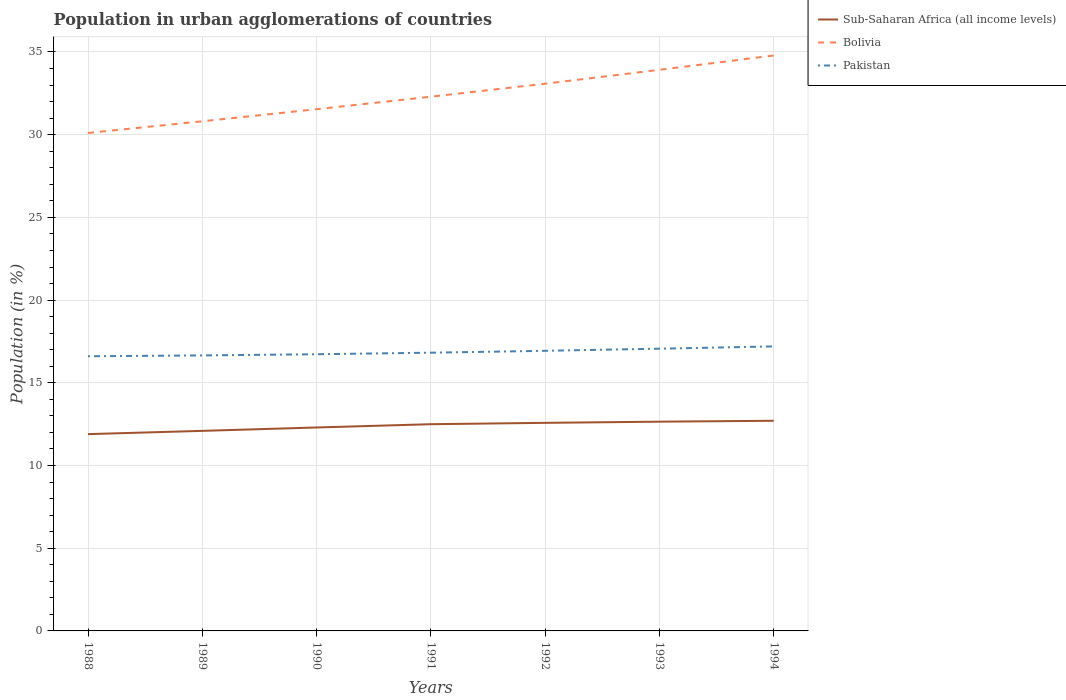Does the line corresponding to Pakistan intersect with the line corresponding to Bolivia?
Ensure brevity in your answer.  No. Is the number of lines equal to the number of legend labels?
Your response must be concise. Yes. Across all years, what is the maximum percentage of population in urban agglomerations in Pakistan?
Keep it short and to the point. 16.61. What is the total percentage of population in urban agglomerations in Bolivia in the graph?
Keep it short and to the point. -0.87. What is the difference between the highest and the second highest percentage of population in urban agglomerations in Bolivia?
Offer a very short reply. 4.68. What is the difference between the highest and the lowest percentage of population in urban agglomerations in Bolivia?
Give a very brief answer. 3. Is the percentage of population in urban agglomerations in Pakistan strictly greater than the percentage of population in urban agglomerations in Sub-Saharan Africa (all income levels) over the years?
Provide a short and direct response. No. What is the difference between two consecutive major ticks on the Y-axis?
Make the answer very short. 5. Are the values on the major ticks of Y-axis written in scientific E-notation?
Your response must be concise. No. Does the graph contain grids?
Offer a terse response. Yes. Where does the legend appear in the graph?
Make the answer very short. Top right. How many legend labels are there?
Make the answer very short. 3. What is the title of the graph?
Make the answer very short. Population in urban agglomerations of countries. What is the label or title of the Y-axis?
Make the answer very short. Population (in %). What is the Population (in %) in Sub-Saharan Africa (all income levels) in 1988?
Your answer should be very brief. 11.9. What is the Population (in %) of Bolivia in 1988?
Provide a succinct answer. 30.11. What is the Population (in %) of Pakistan in 1988?
Offer a terse response. 16.61. What is the Population (in %) of Sub-Saharan Africa (all income levels) in 1989?
Your answer should be very brief. 12.1. What is the Population (in %) in Bolivia in 1989?
Offer a terse response. 30.81. What is the Population (in %) in Pakistan in 1989?
Give a very brief answer. 16.66. What is the Population (in %) in Sub-Saharan Africa (all income levels) in 1990?
Ensure brevity in your answer.  12.3. What is the Population (in %) in Bolivia in 1990?
Keep it short and to the point. 31.54. What is the Population (in %) in Pakistan in 1990?
Keep it short and to the point. 16.73. What is the Population (in %) of Sub-Saharan Africa (all income levels) in 1991?
Keep it short and to the point. 12.5. What is the Population (in %) in Bolivia in 1991?
Provide a short and direct response. 32.3. What is the Population (in %) of Pakistan in 1991?
Ensure brevity in your answer.  16.82. What is the Population (in %) of Sub-Saharan Africa (all income levels) in 1992?
Ensure brevity in your answer.  12.58. What is the Population (in %) in Bolivia in 1992?
Offer a terse response. 33.08. What is the Population (in %) in Pakistan in 1992?
Keep it short and to the point. 16.94. What is the Population (in %) of Sub-Saharan Africa (all income levels) in 1993?
Your answer should be very brief. 12.65. What is the Population (in %) in Bolivia in 1993?
Offer a terse response. 33.92. What is the Population (in %) in Pakistan in 1993?
Your response must be concise. 17.06. What is the Population (in %) of Sub-Saharan Africa (all income levels) in 1994?
Offer a terse response. 12.71. What is the Population (in %) in Bolivia in 1994?
Make the answer very short. 34.79. What is the Population (in %) in Pakistan in 1994?
Offer a terse response. 17.2. Across all years, what is the maximum Population (in %) in Sub-Saharan Africa (all income levels)?
Your response must be concise. 12.71. Across all years, what is the maximum Population (in %) in Bolivia?
Keep it short and to the point. 34.79. Across all years, what is the maximum Population (in %) of Pakistan?
Provide a succinct answer. 17.2. Across all years, what is the minimum Population (in %) in Sub-Saharan Africa (all income levels)?
Provide a succinct answer. 11.9. Across all years, what is the minimum Population (in %) of Bolivia?
Offer a very short reply. 30.11. Across all years, what is the minimum Population (in %) in Pakistan?
Provide a succinct answer. 16.61. What is the total Population (in %) of Sub-Saharan Africa (all income levels) in the graph?
Your answer should be very brief. 86.73. What is the total Population (in %) in Bolivia in the graph?
Provide a succinct answer. 226.55. What is the total Population (in %) in Pakistan in the graph?
Give a very brief answer. 118.01. What is the difference between the Population (in %) of Sub-Saharan Africa (all income levels) in 1988 and that in 1989?
Ensure brevity in your answer.  -0.2. What is the difference between the Population (in %) in Bolivia in 1988 and that in 1989?
Give a very brief answer. -0.71. What is the difference between the Population (in %) of Pakistan in 1988 and that in 1989?
Make the answer very short. -0.05. What is the difference between the Population (in %) of Sub-Saharan Africa (all income levels) in 1988 and that in 1990?
Ensure brevity in your answer.  -0.4. What is the difference between the Population (in %) in Bolivia in 1988 and that in 1990?
Provide a succinct answer. -1.44. What is the difference between the Population (in %) of Pakistan in 1988 and that in 1990?
Provide a succinct answer. -0.12. What is the difference between the Population (in %) in Sub-Saharan Africa (all income levels) in 1988 and that in 1991?
Ensure brevity in your answer.  -0.6. What is the difference between the Population (in %) of Bolivia in 1988 and that in 1991?
Offer a very short reply. -2.19. What is the difference between the Population (in %) of Pakistan in 1988 and that in 1991?
Your answer should be very brief. -0.21. What is the difference between the Population (in %) in Sub-Saharan Africa (all income levels) in 1988 and that in 1992?
Keep it short and to the point. -0.68. What is the difference between the Population (in %) of Bolivia in 1988 and that in 1992?
Your answer should be compact. -2.98. What is the difference between the Population (in %) of Pakistan in 1988 and that in 1992?
Give a very brief answer. -0.33. What is the difference between the Population (in %) of Sub-Saharan Africa (all income levels) in 1988 and that in 1993?
Offer a very short reply. -0.75. What is the difference between the Population (in %) in Bolivia in 1988 and that in 1993?
Provide a short and direct response. -3.82. What is the difference between the Population (in %) in Pakistan in 1988 and that in 1993?
Your answer should be very brief. -0.46. What is the difference between the Population (in %) of Sub-Saharan Africa (all income levels) in 1988 and that in 1994?
Make the answer very short. -0.81. What is the difference between the Population (in %) in Bolivia in 1988 and that in 1994?
Make the answer very short. -4.68. What is the difference between the Population (in %) in Pakistan in 1988 and that in 1994?
Ensure brevity in your answer.  -0.6. What is the difference between the Population (in %) of Sub-Saharan Africa (all income levels) in 1989 and that in 1990?
Offer a terse response. -0.2. What is the difference between the Population (in %) in Bolivia in 1989 and that in 1990?
Offer a very short reply. -0.73. What is the difference between the Population (in %) of Pakistan in 1989 and that in 1990?
Provide a succinct answer. -0.07. What is the difference between the Population (in %) of Sub-Saharan Africa (all income levels) in 1989 and that in 1991?
Offer a very short reply. -0.4. What is the difference between the Population (in %) of Bolivia in 1989 and that in 1991?
Keep it short and to the point. -1.49. What is the difference between the Population (in %) of Pakistan in 1989 and that in 1991?
Your response must be concise. -0.16. What is the difference between the Population (in %) in Sub-Saharan Africa (all income levels) in 1989 and that in 1992?
Offer a very short reply. -0.48. What is the difference between the Population (in %) in Bolivia in 1989 and that in 1992?
Provide a succinct answer. -2.27. What is the difference between the Population (in %) in Pakistan in 1989 and that in 1992?
Keep it short and to the point. -0.28. What is the difference between the Population (in %) in Sub-Saharan Africa (all income levels) in 1989 and that in 1993?
Offer a terse response. -0.56. What is the difference between the Population (in %) of Bolivia in 1989 and that in 1993?
Ensure brevity in your answer.  -3.11. What is the difference between the Population (in %) of Pakistan in 1989 and that in 1993?
Your answer should be very brief. -0.41. What is the difference between the Population (in %) in Sub-Saharan Africa (all income levels) in 1989 and that in 1994?
Offer a very short reply. -0.61. What is the difference between the Population (in %) of Bolivia in 1989 and that in 1994?
Ensure brevity in your answer.  -3.98. What is the difference between the Population (in %) of Pakistan in 1989 and that in 1994?
Offer a very short reply. -0.55. What is the difference between the Population (in %) of Sub-Saharan Africa (all income levels) in 1990 and that in 1991?
Keep it short and to the point. -0.2. What is the difference between the Population (in %) of Bolivia in 1990 and that in 1991?
Your answer should be compact. -0.76. What is the difference between the Population (in %) of Pakistan in 1990 and that in 1991?
Keep it short and to the point. -0.09. What is the difference between the Population (in %) of Sub-Saharan Africa (all income levels) in 1990 and that in 1992?
Offer a terse response. -0.28. What is the difference between the Population (in %) in Bolivia in 1990 and that in 1992?
Your answer should be compact. -1.54. What is the difference between the Population (in %) in Pakistan in 1990 and that in 1992?
Make the answer very short. -0.21. What is the difference between the Population (in %) in Sub-Saharan Africa (all income levels) in 1990 and that in 1993?
Ensure brevity in your answer.  -0.35. What is the difference between the Population (in %) in Bolivia in 1990 and that in 1993?
Provide a succinct answer. -2.38. What is the difference between the Population (in %) in Pakistan in 1990 and that in 1993?
Ensure brevity in your answer.  -0.34. What is the difference between the Population (in %) of Sub-Saharan Africa (all income levels) in 1990 and that in 1994?
Your response must be concise. -0.41. What is the difference between the Population (in %) of Bolivia in 1990 and that in 1994?
Keep it short and to the point. -3.25. What is the difference between the Population (in %) of Pakistan in 1990 and that in 1994?
Offer a terse response. -0.47. What is the difference between the Population (in %) in Sub-Saharan Africa (all income levels) in 1991 and that in 1992?
Your response must be concise. -0.08. What is the difference between the Population (in %) of Bolivia in 1991 and that in 1992?
Give a very brief answer. -0.79. What is the difference between the Population (in %) of Pakistan in 1991 and that in 1992?
Make the answer very short. -0.11. What is the difference between the Population (in %) of Sub-Saharan Africa (all income levels) in 1991 and that in 1993?
Your answer should be very brief. -0.15. What is the difference between the Population (in %) in Bolivia in 1991 and that in 1993?
Your answer should be compact. -1.63. What is the difference between the Population (in %) of Pakistan in 1991 and that in 1993?
Your answer should be compact. -0.24. What is the difference between the Population (in %) of Sub-Saharan Africa (all income levels) in 1991 and that in 1994?
Give a very brief answer. -0.21. What is the difference between the Population (in %) of Bolivia in 1991 and that in 1994?
Your response must be concise. -2.49. What is the difference between the Population (in %) of Pakistan in 1991 and that in 1994?
Make the answer very short. -0.38. What is the difference between the Population (in %) in Sub-Saharan Africa (all income levels) in 1992 and that in 1993?
Keep it short and to the point. -0.07. What is the difference between the Population (in %) of Bolivia in 1992 and that in 1993?
Give a very brief answer. -0.84. What is the difference between the Population (in %) in Pakistan in 1992 and that in 1993?
Provide a succinct answer. -0.13. What is the difference between the Population (in %) of Sub-Saharan Africa (all income levels) in 1992 and that in 1994?
Ensure brevity in your answer.  -0.13. What is the difference between the Population (in %) in Bolivia in 1992 and that in 1994?
Your answer should be very brief. -1.7. What is the difference between the Population (in %) of Pakistan in 1992 and that in 1994?
Your answer should be compact. -0.27. What is the difference between the Population (in %) of Sub-Saharan Africa (all income levels) in 1993 and that in 1994?
Give a very brief answer. -0.06. What is the difference between the Population (in %) in Bolivia in 1993 and that in 1994?
Offer a very short reply. -0.86. What is the difference between the Population (in %) of Pakistan in 1993 and that in 1994?
Provide a short and direct response. -0.14. What is the difference between the Population (in %) of Sub-Saharan Africa (all income levels) in 1988 and the Population (in %) of Bolivia in 1989?
Make the answer very short. -18.91. What is the difference between the Population (in %) in Sub-Saharan Africa (all income levels) in 1988 and the Population (in %) in Pakistan in 1989?
Keep it short and to the point. -4.76. What is the difference between the Population (in %) in Bolivia in 1988 and the Population (in %) in Pakistan in 1989?
Offer a very short reply. 13.45. What is the difference between the Population (in %) of Sub-Saharan Africa (all income levels) in 1988 and the Population (in %) of Bolivia in 1990?
Keep it short and to the point. -19.64. What is the difference between the Population (in %) in Sub-Saharan Africa (all income levels) in 1988 and the Population (in %) in Pakistan in 1990?
Ensure brevity in your answer.  -4.83. What is the difference between the Population (in %) in Bolivia in 1988 and the Population (in %) in Pakistan in 1990?
Your response must be concise. 13.38. What is the difference between the Population (in %) of Sub-Saharan Africa (all income levels) in 1988 and the Population (in %) of Bolivia in 1991?
Offer a very short reply. -20.4. What is the difference between the Population (in %) of Sub-Saharan Africa (all income levels) in 1988 and the Population (in %) of Pakistan in 1991?
Provide a short and direct response. -4.92. What is the difference between the Population (in %) of Bolivia in 1988 and the Population (in %) of Pakistan in 1991?
Keep it short and to the point. 13.28. What is the difference between the Population (in %) of Sub-Saharan Africa (all income levels) in 1988 and the Population (in %) of Bolivia in 1992?
Your response must be concise. -21.19. What is the difference between the Population (in %) in Sub-Saharan Africa (all income levels) in 1988 and the Population (in %) in Pakistan in 1992?
Ensure brevity in your answer.  -5.04. What is the difference between the Population (in %) in Bolivia in 1988 and the Population (in %) in Pakistan in 1992?
Make the answer very short. 13.17. What is the difference between the Population (in %) in Sub-Saharan Africa (all income levels) in 1988 and the Population (in %) in Bolivia in 1993?
Offer a terse response. -22.03. What is the difference between the Population (in %) in Sub-Saharan Africa (all income levels) in 1988 and the Population (in %) in Pakistan in 1993?
Your answer should be very brief. -5.17. What is the difference between the Population (in %) in Bolivia in 1988 and the Population (in %) in Pakistan in 1993?
Offer a terse response. 13.04. What is the difference between the Population (in %) of Sub-Saharan Africa (all income levels) in 1988 and the Population (in %) of Bolivia in 1994?
Provide a short and direct response. -22.89. What is the difference between the Population (in %) of Sub-Saharan Africa (all income levels) in 1988 and the Population (in %) of Pakistan in 1994?
Your answer should be very brief. -5.3. What is the difference between the Population (in %) of Bolivia in 1988 and the Population (in %) of Pakistan in 1994?
Your answer should be compact. 12.9. What is the difference between the Population (in %) in Sub-Saharan Africa (all income levels) in 1989 and the Population (in %) in Bolivia in 1990?
Your answer should be very brief. -19.45. What is the difference between the Population (in %) of Sub-Saharan Africa (all income levels) in 1989 and the Population (in %) of Pakistan in 1990?
Provide a short and direct response. -4.63. What is the difference between the Population (in %) of Bolivia in 1989 and the Population (in %) of Pakistan in 1990?
Give a very brief answer. 14.08. What is the difference between the Population (in %) of Sub-Saharan Africa (all income levels) in 1989 and the Population (in %) of Bolivia in 1991?
Offer a terse response. -20.2. What is the difference between the Population (in %) in Sub-Saharan Africa (all income levels) in 1989 and the Population (in %) in Pakistan in 1991?
Your answer should be compact. -4.73. What is the difference between the Population (in %) in Bolivia in 1989 and the Population (in %) in Pakistan in 1991?
Make the answer very short. 13.99. What is the difference between the Population (in %) of Sub-Saharan Africa (all income levels) in 1989 and the Population (in %) of Bolivia in 1992?
Keep it short and to the point. -20.99. What is the difference between the Population (in %) in Sub-Saharan Africa (all income levels) in 1989 and the Population (in %) in Pakistan in 1992?
Make the answer very short. -4.84. What is the difference between the Population (in %) in Bolivia in 1989 and the Population (in %) in Pakistan in 1992?
Provide a succinct answer. 13.88. What is the difference between the Population (in %) of Sub-Saharan Africa (all income levels) in 1989 and the Population (in %) of Bolivia in 1993?
Give a very brief answer. -21.83. What is the difference between the Population (in %) in Sub-Saharan Africa (all income levels) in 1989 and the Population (in %) in Pakistan in 1993?
Offer a terse response. -4.97. What is the difference between the Population (in %) in Bolivia in 1989 and the Population (in %) in Pakistan in 1993?
Offer a very short reply. 13.75. What is the difference between the Population (in %) of Sub-Saharan Africa (all income levels) in 1989 and the Population (in %) of Bolivia in 1994?
Make the answer very short. -22.69. What is the difference between the Population (in %) of Sub-Saharan Africa (all income levels) in 1989 and the Population (in %) of Pakistan in 1994?
Give a very brief answer. -5.11. What is the difference between the Population (in %) of Bolivia in 1989 and the Population (in %) of Pakistan in 1994?
Give a very brief answer. 13.61. What is the difference between the Population (in %) of Sub-Saharan Africa (all income levels) in 1990 and the Population (in %) of Bolivia in 1991?
Your answer should be compact. -20. What is the difference between the Population (in %) of Sub-Saharan Africa (all income levels) in 1990 and the Population (in %) of Pakistan in 1991?
Give a very brief answer. -4.52. What is the difference between the Population (in %) in Bolivia in 1990 and the Population (in %) in Pakistan in 1991?
Provide a short and direct response. 14.72. What is the difference between the Population (in %) of Sub-Saharan Africa (all income levels) in 1990 and the Population (in %) of Bolivia in 1992?
Your answer should be compact. -20.78. What is the difference between the Population (in %) in Sub-Saharan Africa (all income levels) in 1990 and the Population (in %) in Pakistan in 1992?
Keep it short and to the point. -4.64. What is the difference between the Population (in %) in Bolivia in 1990 and the Population (in %) in Pakistan in 1992?
Your answer should be compact. 14.61. What is the difference between the Population (in %) of Sub-Saharan Africa (all income levels) in 1990 and the Population (in %) of Bolivia in 1993?
Offer a very short reply. -21.62. What is the difference between the Population (in %) of Sub-Saharan Africa (all income levels) in 1990 and the Population (in %) of Pakistan in 1993?
Offer a very short reply. -4.76. What is the difference between the Population (in %) in Bolivia in 1990 and the Population (in %) in Pakistan in 1993?
Your response must be concise. 14.48. What is the difference between the Population (in %) of Sub-Saharan Africa (all income levels) in 1990 and the Population (in %) of Bolivia in 1994?
Ensure brevity in your answer.  -22.49. What is the difference between the Population (in %) in Sub-Saharan Africa (all income levels) in 1990 and the Population (in %) in Pakistan in 1994?
Your answer should be compact. -4.9. What is the difference between the Population (in %) of Bolivia in 1990 and the Population (in %) of Pakistan in 1994?
Your answer should be compact. 14.34. What is the difference between the Population (in %) of Sub-Saharan Africa (all income levels) in 1991 and the Population (in %) of Bolivia in 1992?
Make the answer very short. -20.59. What is the difference between the Population (in %) in Sub-Saharan Africa (all income levels) in 1991 and the Population (in %) in Pakistan in 1992?
Ensure brevity in your answer.  -4.44. What is the difference between the Population (in %) of Bolivia in 1991 and the Population (in %) of Pakistan in 1992?
Offer a terse response. 15.36. What is the difference between the Population (in %) in Sub-Saharan Africa (all income levels) in 1991 and the Population (in %) in Bolivia in 1993?
Provide a short and direct response. -21.43. What is the difference between the Population (in %) of Sub-Saharan Africa (all income levels) in 1991 and the Population (in %) of Pakistan in 1993?
Provide a succinct answer. -4.57. What is the difference between the Population (in %) of Bolivia in 1991 and the Population (in %) of Pakistan in 1993?
Make the answer very short. 15.23. What is the difference between the Population (in %) of Sub-Saharan Africa (all income levels) in 1991 and the Population (in %) of Bolivia in 1994?
Your answer should be compact. -22.29. What is the difference between the Population (in %) in Sub-Saharan Africa (all income levels) in 1991 and the Population (in %) in Pakistan in 1994?
Make the answer very short. -4.7. What is the difference between the Population (in %) of Bolivia in 1991 and the Population (in %) of Pakistan in 1994?
Your response must be concise. 15.1. What is the difference between the Population (in %) in Sub-Saharan Africa (all income levels) in 1992 and the Population (in %) in Bolivia in 1993?
Ensure brevity in your answer.  -21.34. What is the difference between the Population (in %) in Sub-Saharan Africa (all income levels) in 1992 and the Population (in %) in Pakistan in 1993?
Keep it short and to the point. -4.48. What is the difference between the Population (in %) of Bolivia in 1992 and the Population (in %) of Pakistan in 1993?
Provide a succinct answer. 16.02. What is the difference between the Population (in %) of Sub-Saharan Africa (all income levels) in 1992 and the Population (in %) of Bolivia in 1994?
Your response must be concise. -22.21. What is the difference between the Population (in %) of Sub-Saharan Africa (all income levels) in 1992 and the Population (in %) of Pakistan in 1994?
Offer a very short reply. -4.62. What is the difference between the Population (in %) in Bolivia in 1992 and the Population (in %) in Pakistan in 1994?
Provide a succinct answer. 15.88. What is the difference between the Population (in %) in Sub-Saharan Africa (all income levels) in 1993 and the Population (in %) in Bolivia in 1994?
Your answer should be very brief. -22.14. What is the difference between the Population (in %) of Sub-Saharan Africa (all income levels) in 1993 and the Population (in %) of Pakistan in 1994?
Ensure brevity in your answer.  -4.55. What is the difference between the Population (in %) of Bolivia in 1993 and the Population (in %) of Pakistan in 1994?
Your response must be concise. 16.72. What is the average Population (in %) in Sub-Saharan Africa (all income levels) per year?
Offer a terse response. 12.39. What is the average Population (in %) in Bolivia per year?
Offer a terse response. 32.36. What is the average Population (in %) of Pakistan per year?
Make the answer very short. 16.86. In the year 1988, what is the difference between the Population (in %) in Sub-Saharan Africa (all income levels) and Population (in %) in Bolivia?
Your answer should be very brief. -18.21. In the year 1988, what is the difference between the Population (in %) of Sub-Saharan Africa (all income levels) and Population (in %) of Pakistan?
Offer a terse response. -4.71. In the year 1988, what is the difference between the Population (in %) in Bolivia and Population (in %) in Pakistan?
Give a very brief answer. 13.5. In the year 1989, what is the difference between the Population (in %) of Sub-Saharan Africa (all income levels) and Population (in %) of Bolivia?
Provide a short and direct response. -18.72. In the year 1989, what is the difference between the Population (in %) in Sub-Saharan Africa (all income levels) and Population (in %) in Pakistan?
Your answer should be compact. -4.56. In the year 1989, what is the difference between the Population (in %) of Bolivia and Population (in %) of Pakistan?
Offer a terse response. 14.15. In the year 1990, what is the difference between the Population (in %) in Sub-Saharan Africa (all income levels) and Population (in %) in Bolivia?
Offer a terse response. -19.24. In the year 1990, what is the difference between the Population (in %) in Sub-Saharan Africa (all income levels) and Population (in %) in Pakistan?
Make the answer very short. -4.43. In the year 1990, what is the difference between the Population (in %) of Bolivia and Population (in %) of Pakistan?
Offer a terse response. 14.81. In the year 1991, what is the difference between the Population (in %) of Sub-Saharan Africa (all income levels) and Population (in %) of Bolivia?
Provide a succinct answer. -19.8. In the year 1991, what is the difference between the Population (in %) of Sub-Saharan Africa (all income levels) and Population (in %) of Pakistan?
Keep it short and to the point. -4.32. In the year 1991, what is the difference between the Population (in %) of Bolivia and Population (in %) of Pakistan?
Provide a succinct answer. 15.48. In the year 1992, what is the difference between the Population (in %) in Sub-Saharan Africa (all income levels) and Population (in %) in Bolivia?
Give a very brief answer. -20.5. In the year 1992, what is the difference between the Population (in %) of Sub-Saharan Africa (all income levels) and Population (in %) of Pakistan?
Your answer should be very brief. -4.36. In the year 1992, what is the difference between the Population (in %) of Bolivia and Population (in %) of Pakistan?
Offer a very short reply. 16.15. In the year 1993, what is the difference between the Population (in %) of Sub-Saharan Africa (all income levels) and Population (in %) of Bolivia?
Your answer should be very brief. -21.27. In the year 1993, what is the difference between the Population (in %) in Sub-Saharan Africa (all income levels) and Population (in %) in Pakistan?
Provide a succinct answer. -4.41. In the year 1993, what is the difference between the Population (in %) in Bolivia and Population (in %) in Pakistan?
Make the answer very short. 16.86. In the year 1994, what is the difference between the Population (in %) of Sub-Saharan Africa (all income levels) and Population (in %) of Bolivia?
Your answer should be very brief. -22.08. In the year 1994, what is the difference between the Population (in %) in Sub-Saharan Africa (all income levels) and Population (in %) in Pakistan?
Give a very brief answer. -4.5. In the year 1994, what is the difference between the Population (in %) of Bolivia and Population (in %) of Pakistan?
Keep it short and to the point. 17.59. What is the ratio of the Population (in %) in Sub-Saharan Africa (all income levels) in 1988 to that in 1989?
Provide a short and direct response. 0.98. What is the ratio of the Population (in %) of Bolivia in 1988 to that in 1989?
Provide a short and direct response. 0.98. What is the ratio of the Population (in %) in Sub-Saharan Africa (all income levels) in 1988 to that in 1990?
Your answer should be compact. 0.97. What is the ratio of the Population (in %) in Bolivia in 1988 to that in 1990?
Your response must be concise. 0.95. What is the ratio of the Population (in %) of Sub-Saharan Africa (all income levels) in 1988 to that in 1991?
Offer a very short reply. 0.95. What is the ratio of the Population (in %) in Bolivia in 1988 to that in 1991?
Give a very brief answer. 0.93. What is the ratio of the Population (in %) of Pakistan in 1988 to that in 1991?
Your answer should be compact. 0.99. What is the ratio of the Population (in %) in Sub-Saharan Africa (all income levels) in 1988 to that in 1992?
Provide a succinct answer. 0.95. What is the ratio of the Population (in %) of Bolivia in 1988 to that in 1992?
Offer a very short reply. 0.91. What is the ratio of the Population (in %) of Pakistan in 1988 to that in 1992?
Keep it short and to the point. 0.98. What is the ratio of the Population (in %) in Sub-Saharan Africa (all income levels) in 1988 to that in 1993?
Your response must be concise. 0.94. What is the ratio of the Population (in %) of Bolivia in 1988 to that in 1993?
Give a very brief answer. 0.89. What is the ratio of the Population (in %) of Pakistan in 1988 to that in 1993?
Provide a short and direct response. 0.97. What is the ratio of the Population (in %) of Sub-Saharan Africa (all income levels) in 1988 to that in 1994?
Provide a succinct answer. 0.94. What is the ratio of the Population (in %) in Bolivia in 1988 to that in 1994?
Provide a short and direct response. 0.87. What is the ratio of the Population (in %) of Pakistan in 1988 to that in 1994?
Offer a very short reply. 0.97. What is the ratio of the Population (in %) of Sub-Saharan Africa (all income levels) in 1989 to that in 1990?
Offer a terse response. 0.98. What is the ratio of the Population (in %) in Bolivia in 1989 to that in 1990?
Offer a very short reply. 0.98. What is the ratio of the Population (in %) of Pakistan in 1989 to that in 1990?
Your response must be concise. 1. What is the ratio of the Population (in %) of Sub-Saharan Africa (all income levels) in 1989 to that in 1991?
Your response must be concise. 0.97. What is the ratio of the Population (in %) of Bolivia in 1989 to that in 1991?
Provide a succinct answer. 0.95. What is the ratio of the Population (in %) in Pakistan in 1989 to that in 1991?
Provide a succinct answer. 0.99. What is the ratio of the Population (in %) of Sub-Saharan Africa (all income levels) in 1989 to that in 1992?
Your answer should be very brief. 0.96. What is the ratio of the Population (in %) in Bolivia in 1989 to that in 1992?
Provide a short and direct response. 0.93. What is the ratio of the Population (in %) in Pakistan in 1989 to that in 1992?
Offer a very short reply. 0.98. What is the ratio of the Population (in %) in Sub-Saharan Africa (all income levels) in 1989 to that in 1993?
Provide a succinct answer. 0.96. What is the ratio of the Population (in %) of Bolivia in 1989 to that in 1993?
Keep it short and to the point. 0.91. What is the ratio of the Population (in %) in Pakistan in 1989 to that in 1993?
Your answer should be very brief. 0.98. What is the ratio of the Population (in %) in Bolivia in 1989 to that in 1994?
Your response must be concise. 0.89. What is the ratio of the Population (in %) of Pakistan in 1989 to that in 1994?
Your answer should be compact. 0.97. What is the ratio of the Population (in %) in Sub-Saharan Africa (all income levels) in 1990 to that in 1991?
Keep it short and to the point. 0.98. What is the ratio of the Population (in %) in Bolivia in 1990 to that in 1991?
Make the answer very short. 0.98. What is the ratio of the Population (in %) of Sub-Saharan Africa (all income levels) in 1990 to that in 1992?
Offer a terse response. 0.98. What is the ratio of the Population (in %) in Bolivia in 1990 to that in 1992?
Provide a succinct answer. 0.95. What is the ratio of the Population (in %) of Pakistan in 1990 to that in 1992?
Provide a short and direct response. 0.99. What is the ratio of the Population (in %) of Sub-Saharan Africa (all income levels) in 1990 to that in 1993?
Ensure brevity in your answer.  0.97. What is the ratio of the Population (in %) in Bolivia in 1990 to that in 1993?
Provide a succinct answer. 0.93. What is the ratio of the Population (in %) in Pakistan in 1990 to that in 1993?
Your answer should be compact. 0.98. What is the ratio of the Population (in %) of Bolivia in 1990 to that in 1994?
Your answer should be very brief. 0.91. What is the ratio of the Population (in %) in Pakistan in 1990 to that in 1994?
Ensure brevity in your answer.  0.97. What is the ratio of the Population (in %) in Sub-Saharan Africa (all income levels) in 1991 to that in 1992?
Your response must be concise. 0.99. What is the ratio of the Population (in %) in Bolivia in 1991 to that in 1992?
Your answer should be very brief. 0.98. What is the ratio of the Population (in %) of Sub-Saharan Africa (all income levels) in 1991 to that in 1993?
Provide a succinct answer. 0.99. What is the ratio of the Population (in %) in Bolivia in 1991 to that in 1993?
Your response must be concise. 0.95. What is the ratio of the Population (in %) of Pakistan in 1991 to that in 1993?
Offer a terse response. 0.99. What is the ratio of the Population (in %) in Sub-Saharan Africa (all income levels) in 1991 to that in 1994?
Your response must be concise. 0.98. What is the ratio of the Population (in %) of Bolivia in 1991 to that in 1994?
Ensure brevity in your answer.  0.93. What is the ratio of the Population (in %) in Pakistan in 1991 to that in 1994?
Provide a succinct answer. 0.98. What is the ratio of the Population (in %) in Sub-Saharan Africa (all income levels) in 1992 to that in 1993?
Keep it short and to the point. 0.99. What is the ratio of the Population (in %) of Bolivia in 1992 to that in 1993?
Offer a terse response. 0.98. What is the ratio of the Population (in %) of Sub-Saharan Africa (all income levels) in 1992 to that in 1994?
Keep it short and to the point. 0.99. What is the ratio of the Population (in %) of Bolivia in 1992 to that in 1994?
Your answer should be very brief. 0.95. What is the ratio of the Population (in %) of Pakistan in 1992 to that in 1994?
Your answer should be very brief. 0.98. What is the ratio of the Population (in %) in Sub-Saharan Africa (all income levels) in 1993 to that in 1994?
Your answer should be very brief. 1. What is the ratio of the Population (in %) of Bolivia in 1993 to that in 1994?
Your answer should be compact. 0.98. What is the ratio of the Population (in %) in Pakistan in 1993 to that in 1994?
Provide a succinct answer. 0.99. What is the difference between the highest and the second highest Population (in %) in Sub-Saharan Africa (all income levels)?
Offer a very short reply. 0.06. What is the difference between the highest and the second highest Population (in %) of Bolivia?
Ensure brevity in your answer.  0.86. What is the difference between the highest and the second highest Population (in %) of Pakistan?
Give a very brief answer. 0.14. What is the difference between the highest and the lowest Population (in %) in Sub-Saharan Africa (all income levels)?
Keep it short and to the point. 0.81. What is the difference between the highest and the lowest Population (in %) in Bolivia?
Provide a short and direct response. 4.68. What is the difference between the highest and the lowest Population (in %) in Pakistan?
Offer a very short reply. 0.6. 